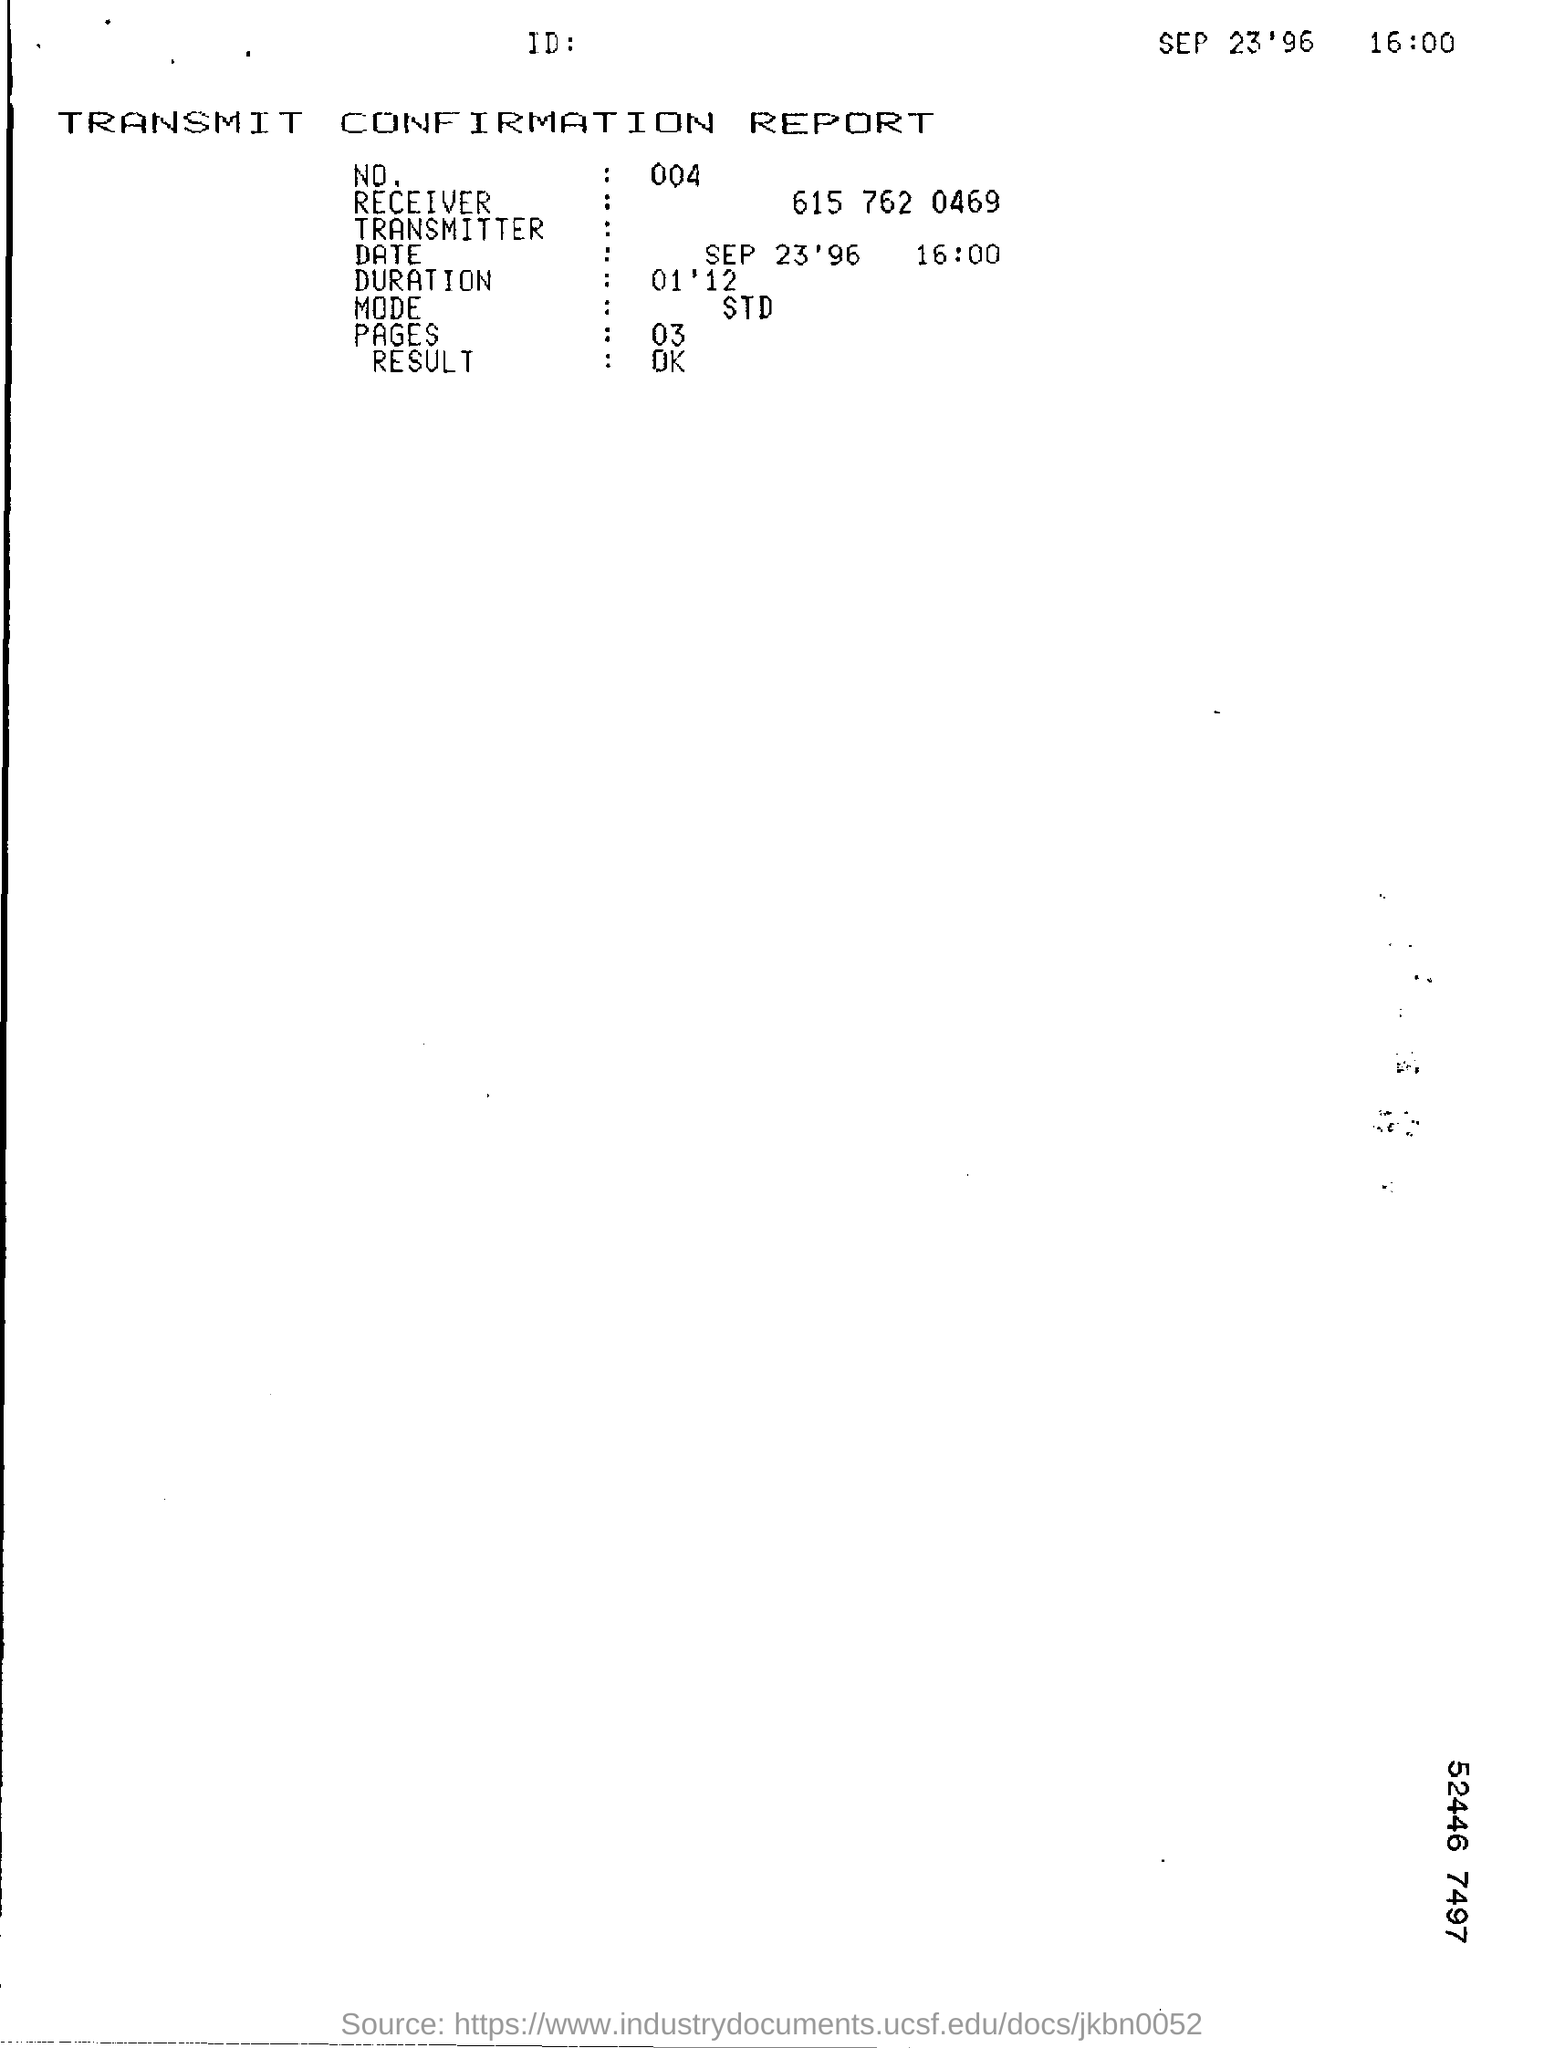Outline some significant characteristics in this image. The TRANSMIT CONFIRMATION REPORT resulted in "OK. 